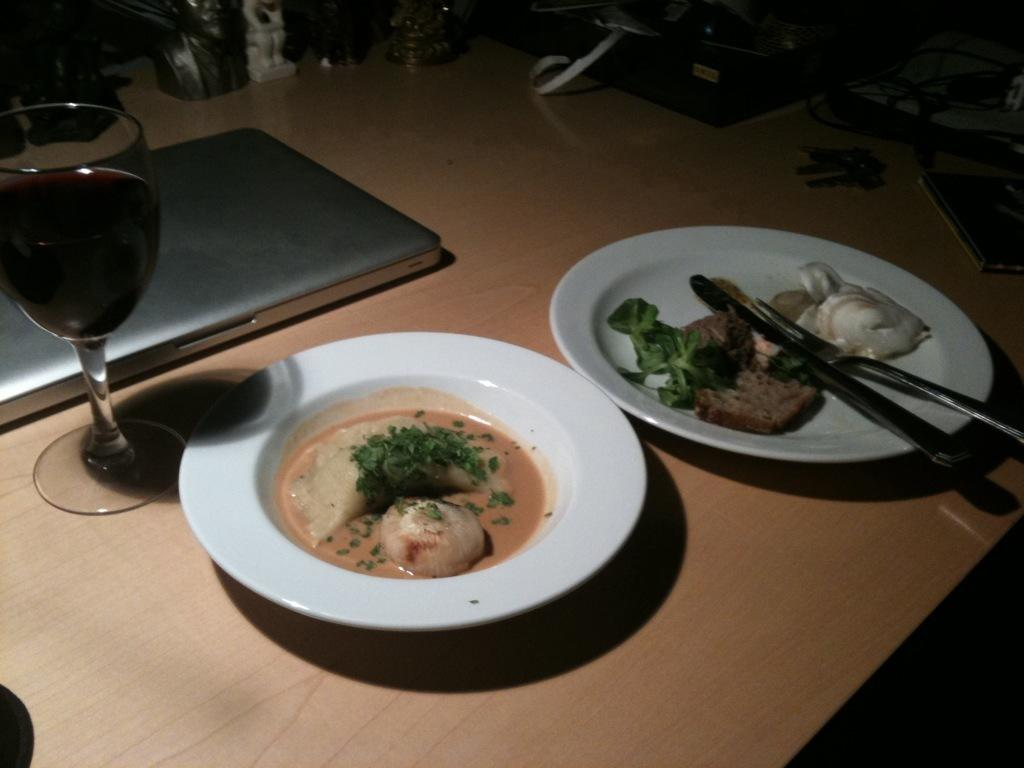What is in the image that people typically use for drinking? There is a glass in the image. What can be seen on the plates in the image? There are food items on plates in the image. What utensils are visible in the image? Spoons are visible in the image. What objects are used for unlocking doors or starting vehicles? There are keys in the image. What electronic device is present in the image? A laptop is present in the image. What is the color of the table in the image? The table in the image is brown. How many cakes are being played in the game on the table? There are no cakes or games present in the image; it features a glass, food items, spoons, keys, a laptop, and objects on a brown color table. 